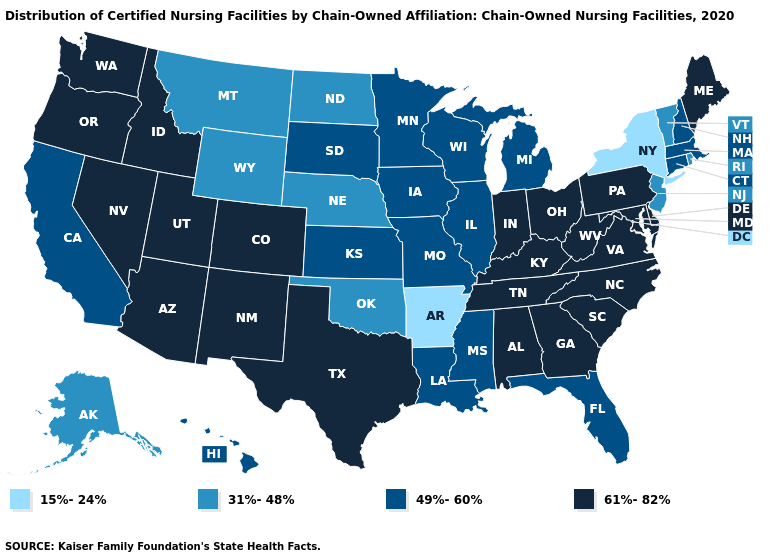What is the value of North Carolina?
Write a very short answer. 61%-82%. Is the legend a continuous bar?
Short answer required. No. What is the value of New Hampshire?
Keep it brief. 49%-60%. Does the first symbol in the legend represent the smallest category?
Concise answer only. Yes. What is the value of New Hampshire?
Give a very brief answer. 49%-60%. Name the states that have a value in the range 61%-82%?
Quick response, please. Alabama, Arizona, Colorado, Delaware, Georgia, Idaho, Indiana, Kentucky, Maine, Maryland, Nevada, New Mexico, North Carolina, Ohio, Oregon, Pennsylvania, South Carolina, Tennessee, Texas, Utah, Virginia, Washington, West Virginia. Name the states that have a value in the range 15%-24%?
Write a very short answer. Arkansas, New York. Which states have the lowest value in the Northeast?
Keep it brief. New York. Among the states that border Utah , which have the highest value?
Be succinct. Arizona, Colorado, Idaho, Nevada, New Mexico. What is the value of West Virginia?
Concise answer only. 61%-82%. What is the value of Rhode Island?
Write a very short answer. 31%-48%. Name the states that have a value in the range 15%-24%?
Keep it brief. Arkansas, New York. Is the legend a continuous bar?
Be succinct. No. Does Kentucky have the lowest value in the USA?
Answer briefly. No. 